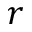Convert formula to latex. <formula><loc_0><loc_0><loc_500><loc_500>r</formula> 